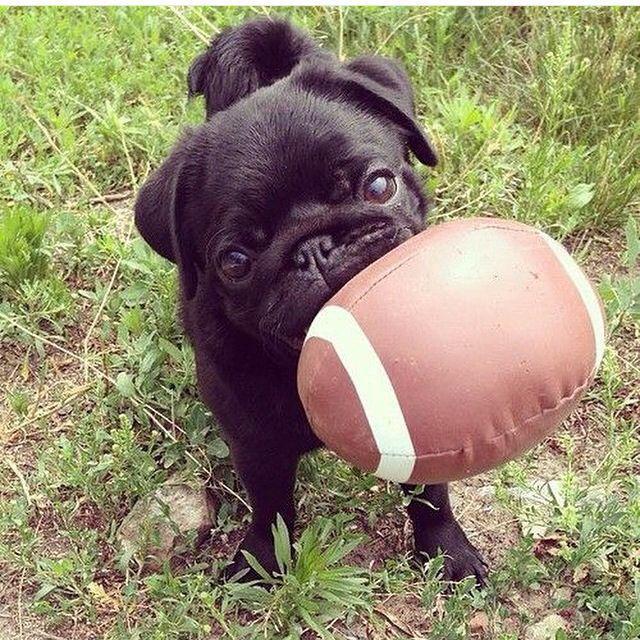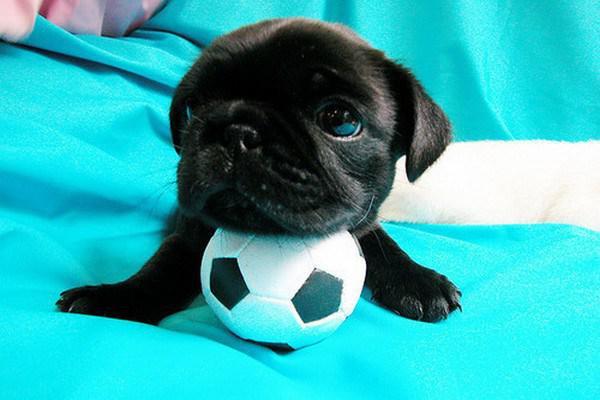The first image is the image on the left, the second image is the image on the right. Examine the images to the left and right. Is the description "At least one of the dogs is playing with a ball that has spikes on it." accurate? Answer yes or no. No. The first image is the image on the left, the second image is the image on the right. For the images shown, is this caption "There are two dogs." true? Answer yes or no. Yes. 